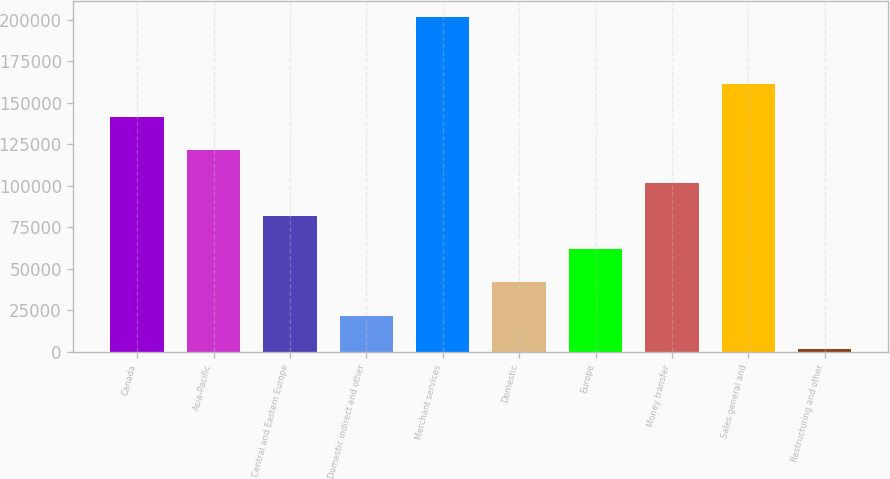<chart> <loc_0><loc_0><loc_500><loc_500><bar_chart><fcel>Canada<fcel>Asia-Pacific<fcel>Central and Eastern Europe<fcel>Domestic indirect and other<fcel>Merchant services<fcel>Domestic<fcel>Europe<fcel>Money transfer<fcel>Sales general and<fcel>Restructuring and other<nl><fcel>141558<fcel>121589<fcel>81649.4<fcel>21740.6<fcel>201467<fcel>41710.2<fcel>61679.8<fcel>101619<fcel>161528<fcel>1771<nl></chart> 